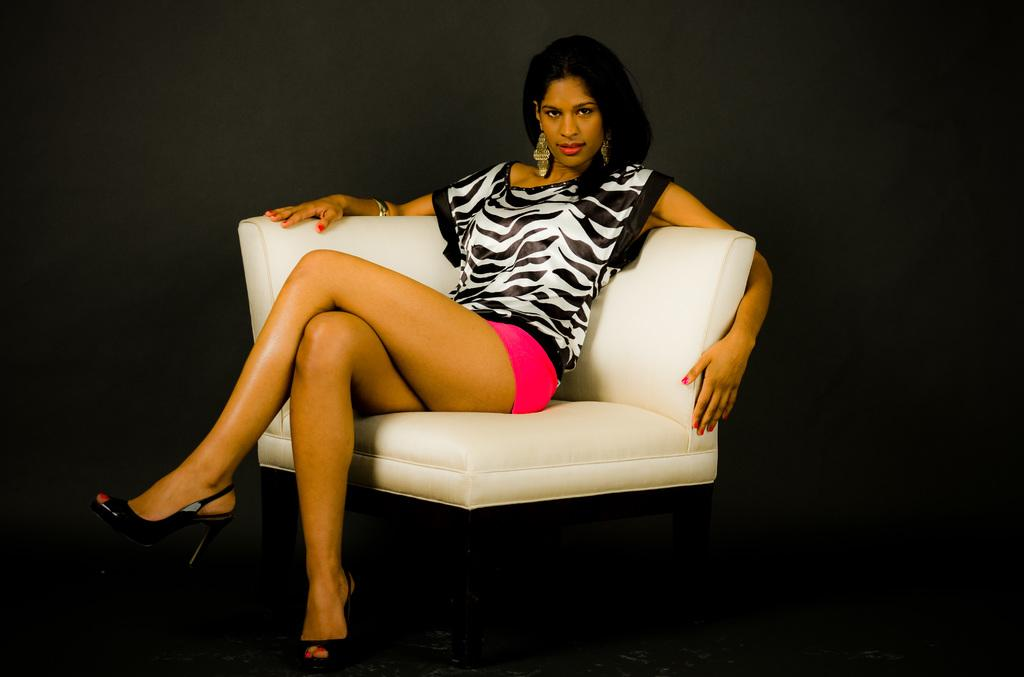What is the main subject of the image? The main subject of the image is a woman. What is the woman doing in the image? The woman is sitting on a sofa chair. What is the woman's focus in the image? The woman is staring at something. What type of hair product is the woman using in the image? There is no indication in the image that the woman is using any hair product. Can you tell me how many monkeys are sitting next to the woman in the image? There are no monkeys present in the image. 